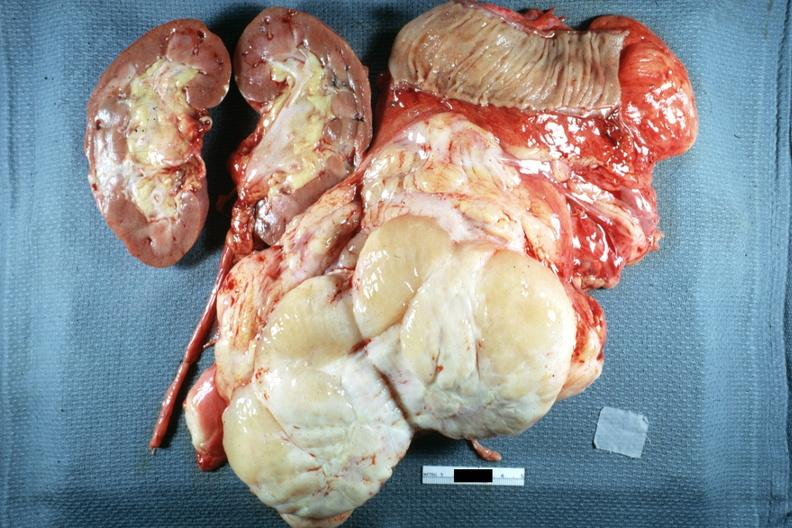what is present?
Answer the question using a single word or phrase. Retroperitoneal liposarcoma 